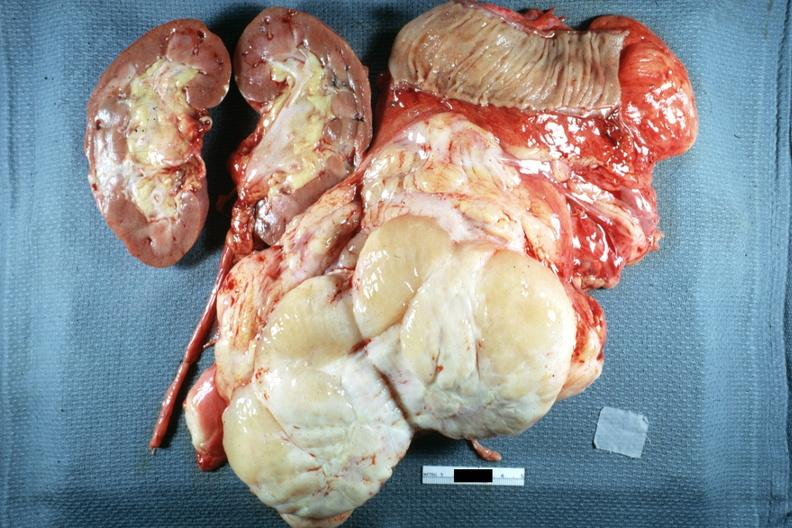what is present?
Answer the question using a single word or phrase. Retroperitoneal liposarcoma 